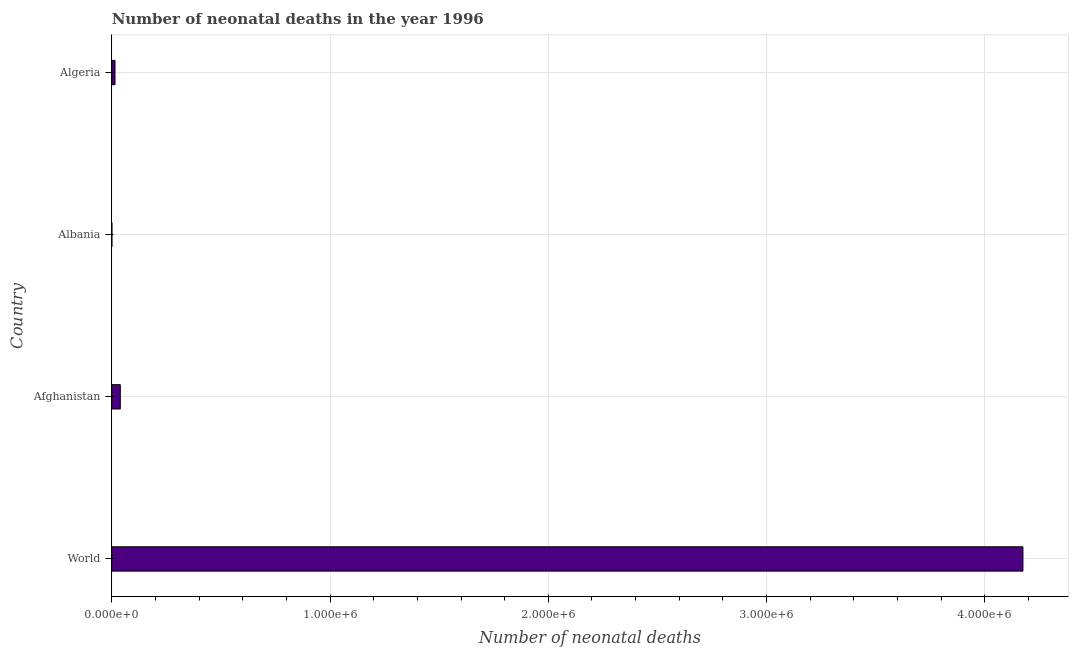What is the title of the graph?
Keep it short and to the point. Number of neonatal deaths in the year 1996. What is the label or title of the X-axis?
Offer a terse response. Number of neonatal deaths. What is the number of neonatal deaths in Albania?
Ensure brevity in your answer.  746. Across all countries, what is the maximum number of neonatal deaths?
Keep it short and to the point. 4.17e+06. Across all countries, what is the minimum number of neonatal deaths?
Keep it short and to the point. 746. In which country was the number of neonatal deaths minimum?
Provide a succinct answer. Albania. What is the sum of the number of neonatal deaths?
Offer a terse response. 4.23e+06. What is the difference between the number of neonatal deaths in Afghanistan and Albania?
Keep it short and to the point. 3.84e+04. What is the average number of neonatal deaths per country?
Provide a succinct answer. 1.06e+06. What is the median number of neonatal deaths?
Your answer should be very brief. 2.70e+04. In how many countries, is the number of neonatal deaths greater than 200000 ?
Your answer should be very brief. 1. What is the ratio of the number of neonatal deaths in Algeria to that in World?
Provide a short and direct response. 0. Is the number of neonatal deaths in Afghanistan less than that in Algeria?
Offer a terse response. No. What is the difference between the highest and the second highest number of neonatal deaths?
Make the answer very short. 4.14e+06. Is the sum of the number of neonatal deaths in Afghanistan and Algeria greater than the maximum number of neonatal deaths across all countries?
Your answer should be compact. No. What is the difference between the highest and the lowest number of neonatal deaths?
Provide a short and direct response. 4.17e+06. In how many countries, is the number of neonatal deaths greater than the average number of neonatal deaths taken over all countries?
Your answer should be compact. 1. How many countries are there in the graph?
Your answer should be very brief. 4. What is the difference between two consecutive major ticks on the X-axis?
Offer a terse response. 1.00e+06. Are the values on the major ticks of X-axis written in scientific E-notation?
Give a very brief answer. Yes. What is the Number of neonatal deaths in World?
Ensure brevity in your answer.  4.17e+06. What is the Number of neonatal deaths of Afghanistan?
Provide a succinct answer. 3.92e+04. What is the Number of neonatal deaths of Albania?
Your answer should be very brief. 746. What is the Number of neonatal deaths of Algeria?
Ensure brevity in your answer.  1.49e+04. What is the difference between the Number of neonatal deaths in World and Afghanistan?
Provide a succinct answer. 4.14e+06. What is the difference between the Number of neonatal deaths in World and Albania?
Offer a terse response. 4.17e+06. What is the difference between the Number of neonatal deaths in World and Algeria?
Provide a short and direct response. 4.16e+06. What is the difference between the Number of neonatal deaths in Afghanistan and Albania?
Give a very brief answer. 3.84e+04. What is the difference between the Number of neonatal deaths in Afghanistan and Algeria?
Offer a very short reply. 2.43e+04. What is the difference between the Number of neonatal deaths in Albania and Algeria?
Provide a short and direct response. -1.41e+04. What is the ratio of the Number of neonatal deaths in World to that in Afghanistan?
Your answer should be compact. 106.51. What is the ratio of the Number of neonatal deaths in World to that in Albania?
Offer a very short reply. 5595.45. What is the ratio of the Number of neonatal deaths in World to that in Algeria?
Offer a very short reply. 280.47. What is the ratio of the Number of neonatal deaths in Afghanistan to that in Albania?
Keep it short and to the point. 52.53. What is the ratio of the Number of neonatal deaths in Afghanistan to that in Algeria?
Make the answer very short. 2.63. What is the ratio of the Number of neonatal deaths in Albania to that in Algeria?
Your response must be concise. 0.05. 